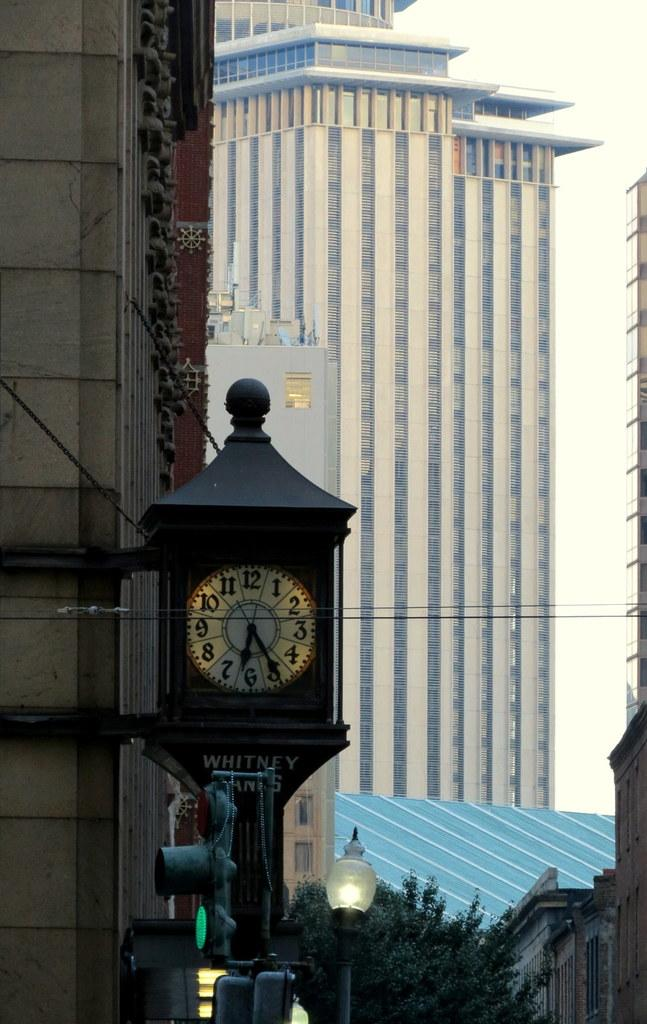<image>
Relay a brief, clear account of the picture shown. An outdoor clock with the word "Whitney" on it next to a tall building. 